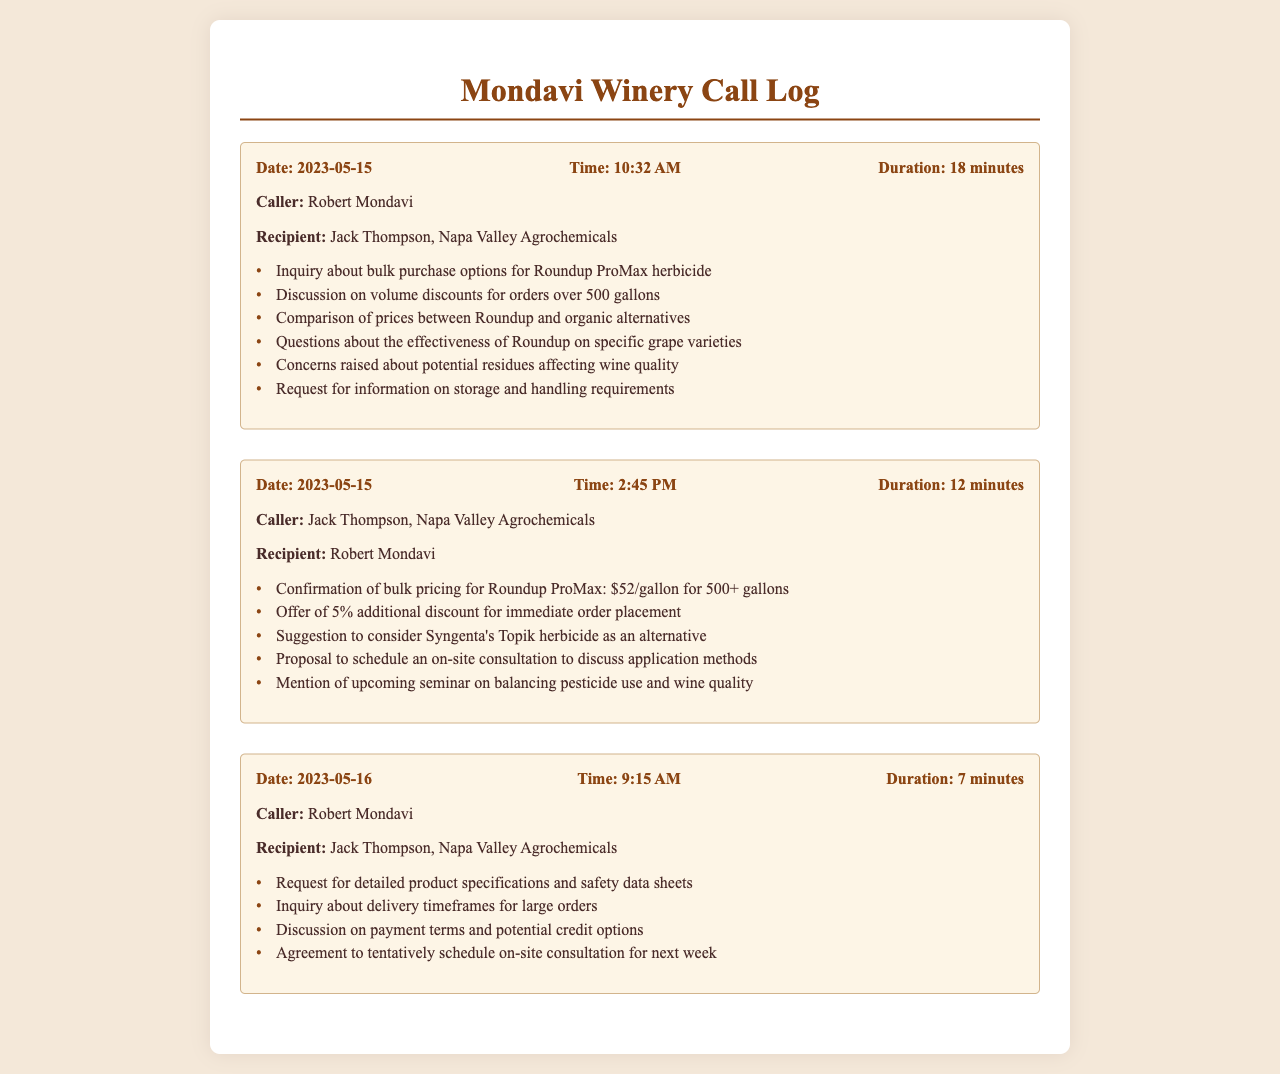What is the name of the caller on May 15th, 2023 at 10:32 AM? The caller is Robert Mondavi as listed in the document.
Answer: Robert Mondavi What was the duration of the call made at 2:45 PM on May 15th, 2023? The duration of the call is 12 minutes as noted in the document.
Answer: 12 minutes What was the bulk pricing for Roundup ProMax offered? The bulk pricing for Roundup ProMax is specified as $52/gallon for orders of 500 or more gallons.
Answer: $52/gallon Which alternative herbicide was suggested during the call? The alternative herbicide mentioned is Syngenta's Topik, noted in the document.
Answer: Syngenta's Topik What specific concerns did Robert Mondavi raise about pesticide use? He raised concerns regarding potential residues affecting wine quality, as stated in the call log.
Answer: Potential residues affecting wine quality How much additional discount was offered for immediate order placement? A 5% additional discount was offered for placing the order immediately.
Answer: 5% What was agreed upon during the last call on May 16th, 2023? They tentatively scheduled an on-site consultation for the following week.
Answer: On-site consultation for next week What type of document is this? This document is a call log detailing conversations about pesticide purchases.
Answer: Call log 